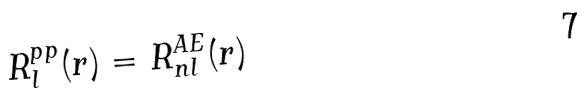Convert formula to latex. <formula><loc_0><loc_0><loc_500><loc_500>R _ { l } ^ { p p } ( r ) = R _ { n l } ^ { A E } ( r )</formula> 